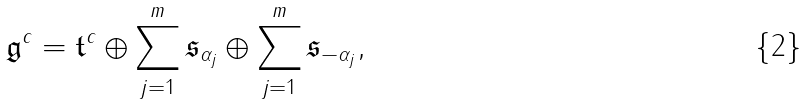<formula> <loc_0><loc_0><loc_500><loc_500>\mathfrak { g } ^ { c } = \mathfrak { t } ^ { c } \oplus \sum _ { j = 1 } ^ { m } \mathfrak { s } _ { \alpha _ { j } } \oplus \sum _ { j = 1 } ^ { m } \mathfrak { s } _ { - \alpha _ { j } } ,</formula> 